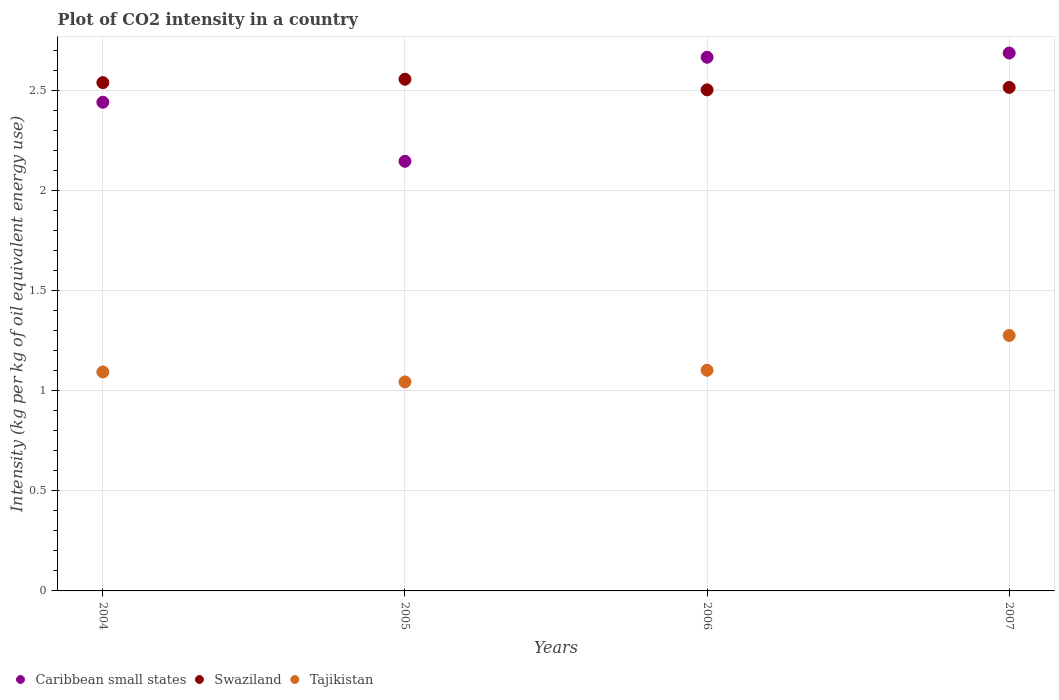How many different coloured dotlines are there?
Provide a short and direct response. 3. What is the CO2 intensity in in Tajikistan in 2005?
Provide a short and direct response. 1.04. Across all years, what is the maximum CO2 intensity in in Swaziland?
Provide a short and direct response. 2.55. Across all years, what is the minimum CO2 intensity in in Caribbean small states?
Provide a succinct answer. 2.15. In which year was the CO2 intensity in in Caribbean small states maximum?
Give a very brief answer. 2007. In which year was the CO2 intensity in in Tajikistan minimum?
Keep it short and to the point. 2005. What is the total CO2 intensity in in Tajikistan in the graph?
Provide a short and direct response. 4.51. What is the difference between the CO2 intensity in in Tajikistan in 2004 and that in 2006?
Your answer should be compact. -0.01. What is the difference between the CO2 intensity in in Tajikistan in 2004 and the CO2 intensity in in Swaziland in 2007?
Offer a terse response. -1.42. What is the average CO2 intensity in in Swaziland per year?
Your response must be concise. 2.53. In the year 2006, what is the difference between the CO2 intensity in in Caribbean small states and CO2 intensity in in Swaziland?
Your answer should be compact. 0.16. What is the ratio of the CO2 intensity in in Swaziland in 2006 to that in 2007?
Your response must be concise. 1. Is the CO2 intensity in in Swaziland in 2004 less than that in 2007?
Your response must be concise. No. Is the difference between the CO2 intensity in in Caribbean small states in 2006 and 2007 greater than the difference between the CO2 intensity in in Swaziland in 2006 and 2007?
Your answer should be very brief. No. What is the difference between the highest and the second highest CO2 intensity in in Caribbean small states?
Your answer should be very brief. 0.02. What is the difference between the highest and the lowest CO2 intensity in in Caribbean small states?
Provide a short and direct response. 0.54. Is the sum of the CO2 intensity in in Swaziland in 2005 and 2006 greater than the maximum CO2 intensity in in Tajikistan across all years?
Offer a very short reply. Yes. Does the CO2 intensity in in Caribbean small states monotonically increase over the years?
Offer a very short reply. No. Is the CO2 intensity in in Tajikistan strictly greater than the CO2 intensity in in Swaziland over the years?
Make the answer very short. No. Is the CO2 intensity in in Tajikistan strictly less than the CO2 intensity in in Swaziland over the years?
Provide a succinct answer. Yes. Are the values on the major ticks of Y-axis written in scientific E-notation?
Ensure brevity in your answer.  No. Where does the legend appear in the graph?
Provide a short and direct response. Bottom left. What is the title of the graph?
Offer a terse response. Plot of CO2 intensity in a country. Does "Faeroe Islands" appear as one of the legend labels in the graph?
Ensure brevity in your answer.  No. What is the label or title of the Y-axis?
Keep it short and to the point. Intensity (kg per kg of oil equivalent energy use). What is the Intensity (kg per kg of oil equivalent energy use) of Caribbean small states in 2004?
Make the answer very short. 2.44. What is the Intensity (kg per kg of oil equivalent energy use) in Swaziland in 2004?
Ensure brevity in your answer.  2.54. What is the Intensity (kg per kg of oil equivalent energy use) of Tajikistan in 2004?
Your answer should be very brief. 1.09. What is the Intensity (kg per kg of oil equivalent energy use) of Caribbean small states in 2005?
Make the answer very short. 2.15. What is the Intensity (kg per kg of oil equivalent energy use) in Swaziland in 2005?
Provide a succinct answer. 2.55. What is the Intensity (kg per kg of oil equivalent energy use) in Tajikistan in 2005?
Ensure brevity in your answer.  1.04. What is the Intensity (kg per kg of oil equivalent energy use) in Caribbean small states in 2006?
Your response must be concise. 2.66. What is the Intensity (kg per kg of oil equivalent energy use) of Swaziland in 2006?
Provide a short and direct response. 2.5. What is the Intensity (kg per kg of oil equivalent energy use) in Tajikistan in 2006?
Your response must be concise. 1.1. What is the Intensity (kg per kg of oil equivalent energy use) of Caribbean small states in 2007?
Ensure brevity in your answer.  2.69. What is the Intensity (kg per kg of oil equivalent energy use) of Swaziland in 2007?
Ensure brevity in your answer.  2.51. What is the Intensity (kg per kg of oil equivalent energy use) in Tajikistan in 2007?
Keep it short and to the point. 1.28. Across all years, what is the maximum Intensity (kg per kg of oil equivalent energy use) in Caribbean small states?
Your answer should be compact. 2.69. Across all years, what is the maximum Intensity (kg per kg of oil equivalent energy use) in Swaziland?
Offer a very short reply. 2.55. Across all years, what is the maximum Intensity (kg per kg of oil equivalent energy use) of Tajikistan?
Give a very brief answer. 1.28. Across all years, what is the minimum Intensity (kg per kg of oil equivalent energy use) of Caribbean small states?
Ensure brevity in your answer.  2.15. Across all years, what is the minimum Intensity (kg per kg of oil equivalent energy use) of Swaziland?
Ensure brevity in your answer.  2.5. Across all years, what is the minimum Intensity (kg per kg of oil equivalent energy use) of Tajikistan?
Keep it short and to the point. 1.04. What is the total Intensity (kg per kg of oil equivalent energy use) of Caribbean small states in the graph?
Your answer should be very brief. 9.94. What is the total Intensity (kg per kg of oil equivalent energy use) of Swaziland in the graph?
Your response must be concise. 10.11. What is the total Intensity (kg per kg of oil equivalent energy use) in Tajikistan in the graph?
Keep it short and to the point. 4.51. What is the difference between the Intensity (kg per kg of oil equivalent energy use) in Caribbean small states in 2004 and that in 2005?
Keep it short and to the point. 0.29. What is the difference between the Intensity (kg per kg of oil equivalent energy use) in Swaziland in 2004 and that in 2005?
Provide a succinct answer. -0.02. What is the difference between the Intensity (kg per kg of oil equivalent energy use) of Tajikistan in 2004 and that in 2005?
Your answer should be compact. 0.05. What is the difference between the Intensity (kg per kg of oil equivalent energy use) in Caribbean small states in 2004 and that in 2006?
Your answer should be very brief. -0.22. What is the difference between the Intensity (kg per kg of oil equivalent energy use) in Swaziland in 2004 and that in 2006?
Offer a very short reply. 0.04. What is the difference between the Intensity (kg per kg of oil equivalent energy use) in Tajikistan in 2004 and that in 2006?
Offer a very short reply. -0.01. What is the difference between the Intensity (kg per kg of oil equivalent energy use) of Caribbean small states in 2004 and that in 2007?
Provide a succinct answer. -0.25. What is the difference between the Intensity (kg per kg of oil equivalent energy use) in Swaziland in 2004 and that in 2007?
Your answer should be very brief. 0.02. What is the difference between the Intensity (kg per kg of oil equivalent energy use) in Tajikistan in 2004 and that in 2007?
Your response must be concise. -0.18. What is the difference between the Intensity (kg per kg of oil equivalent energy use) in Caribbean small states in 2005 and that in 2006?
Your response must be concise. -0.52. What is the difference between the Intensity (kg per kg of oil equivalent energy use) in Swaziland in 2005 and that in 2006?
Offer a very short reply. 0.05. What is the difference between the Intensity (kg per kg of oil equivalent energy use) of Tajikistan in 2005 and that in 2006?
Give a very brief answer. -0.06. What is the difference between the Intensity (kg per kg of oil equivalent energy use) of Caribbean small states in 2005 and that in 2007?
Your answer should be very brief. -0.54. What is the difference between the Intensity (kg per kg of oil equivalent energy use) in Swaziland in 2005 and that in 2007?
Provide a short and direct response. 0.04. What is the difference between the Intensity (kg per kg of oil equivalent energy use) of Tajikistan in 2005 and that in 2007?
Offer a very short reply. -0.23. What is the difference between the Intensity (kg per kg of oil equivalent energy use) in Caribbean small states in 2006 and that in 2007?
Provide a short and direct response. -0.02. What is the difference between the Intensity (kg per kg of oil equivalent energy use) in Swaziland in 2006 and that in 2007?
Keep it short and to the point. -0.01. What is the difference between the Intensity (kg per kg of oil equivalent energy use) in Tajikistan in 2006 and that in 2007?
Ensure brevity in your answer.  -0.17. What is the difference between the Intensity (kg per kg of oil equivalent energy use) of Caribbean small states in 2004 and the Intensity (kg per kg of oil equivalent energy use) of Swaziland in 2005?
Your answer should be very brief. -0.12. What is the difference between the Intensity (kg per kg of oil equivalent energy use) in Caribbean small states in 2004 and the Intensity (kg per kg of oil equivalent energy use) in Tajikistan in 2005?
Keep it short and to the point. 1.4. What is the difference between the Intensity (kg per kg of oil equivalent energy use) in Swaziland in 2004 and the Intensity (kg per kg of oil equivalent energy use) in Tajikistan in 2005?
Keep it short and to the point. 1.49. What is the difference between the Intensity (kg per kg of oil equivalent energy use) in Caribbean small states in 2004 and the Intensity (kg per kg of oil equivalent energy use) in Swaziland in 2006?
Keep it short and to the point. -0.06. What is the difference between the Intensity (kg per kg of oil equivalent energy use) of Caribbean small states in 2004 and the Intensity (kg per kg of oil equivalent energy use) of Tajikistan in 2006?
Make the answer very short. 1.34. What is the difference between the Intensity (kg per kg of oil equivalent energy use) of Swaziland in 2004 and the Intensity (kg per kg of oil equivalent energy use) of Tajikistan in 2006?
Give a very brief answer. 1.44. What is the difference between the Intensity (kg per kg of oil equivalent energy use) of Caribbean small states in 2004 and the Intensity (kg per kg of oil equivalent energy use) of Swaziland in 2007?
Make the answer very short. -0.07. What is the difference between the Intensity (kg per kg of oil equivalent energy use) of Caribbean small states in 2004 and the Intensity (kg per kg of oil equivalent energy use) of Tajikistan in 2007?
Give a very brief answer. 1.16. What is the difference between the Intensity (kg per kg of oil equivalent energy use) in Swaziland in 2004 and the Intensity (kg per kg of oil equivalent energy use) in Tajikistan in 2007?
Your answer should be compact. 1.26. What is the difference between the Intensity (kg per kg of oil equivalent energy use) in Caribbean small states in 2005 and the Intensity (kg per kg of oil equivalent energy use) in Swaziland in 2006?
Your answer should be compact. -0.36. What is the difference between the Intensity (kg per kg of oil equivalent energy use) in Caribbean small states in 2005 and the Intensity (kg per kg of oil equivalent energy use) in Tajikistan in 2006?
Your response must be concise. 1.04. What is the difference between the Intensity (kg per kg of oil equivalent energy use) of Swaziland in 2005 and the Intensity (kg per kg of oil equivalent energy use) of Tajikistan in 2006?
Offer a very short reply. 1.45. What is the difference between the Intensity (kg per kg of oil equivalent energy use) in Caribbean small states in 2005 and the Intensity (kg per kg of oil equivalent energy use) in Swaziland in 2007?
Your response must be concise. -0.37. What is the difference between the Intensity (kg per kg of oil equivalent energy use) in Caribbean small states in 2005 and the Intensity (kg per kg of oil equivalent energy use) in Tajikistan in 2007?
Your answer should be compact. 0.87. What is the difference between the Intensity (kg per kg of oil equivalent energy use) in Swaziland in 2005 and the Intensity (kg per kg of oil equivalent energy use) in Tajikistan in 2007?
Make the answer very short. 1.28. What is the difference between the Intensity (kg per kg of oil equivalent energy use) of Caribbean small states in 2006 and the Intensity (kg per kg of oil equivalent energy use) of Swaziland in 2007?
Offer a very short reply. 0.15. What is the difference between the Intensity (kg per kg of oil equivalent energy use) of Caribbean small states in 2006 and the Intensity (kg per kg of oil equivalent energy use) of Tajikistan in 2007?
Your response must be concise. 1.39. What is the difference between the Intensity (kg per kg of oil equivalent energy use) of Swaziland in 2006 and the Intensity (kg per kg of oil equivalent energy use) of Tajikistan in 2007?
Your answer should be compact. 1.23. What is the average Intensity (kg per kg of oil equivalent energy use) in Caribbean small states per year?
Your response must be concise. 2.48. What is the average Intensity (kg per kg of oil equivalent energy use) in Swaziland per year?
Give a very brief answer. 2.53. What is the average Intensity (kg per kg of oil equivalent energy use) in Tajikistan per year?
Provide a short and direct response. 1.13. In the year 2004, what is the difference between the Intensity (kg per kg of oil equivalent energy use) of Caribbean small states and Intensity (kg per kg of oil equivalent energy use) of Swaziland?
Your answer should be very brief. -0.1. In the year 2004, what is the difference between the Intensity (kg per kg of oil equivalent energy use) of Caribbean small states and Intensity (kg per kg of oil equivalent energy use) of Tajikistan?
Keep it short and to the point. 1.35. In the year 2004, what is the difference between the Intensity (kg per kg of oil equivalent energy use) of Swaziland and Intensity (kg per kg of oil equivalent energy use) of Tajikistan?
Your answer should be compact. 1.44. In the year 2005, what is the difference between the Intensity (kg per kg of oil equivalent energy use) in Caribbean small states and Intensity (kg per kg of oil equivalent energy use) in Swaziland?
Provide a succinct answer. -0.41. In the year 2005, what is the difference between the Intensity (kg per kg of oil equivalent energy use) of Caribbean small states and Intensity (kg per kg of oil equivalent energy use) of Tajikistan?
Offer a very short reply. 1.1. In the year 2005, what is the difference between the Intensity (kg per kg of oil equivalent energy use) in Swaziland and Intensity (kg per kg of oil equivalent energy use) in Tajikistan?
Your answer should be compact. 1.51. In the year 2006, what is the difference between the Intensity (kg per kg of oil equivalent energy use) of Caribbean small states and Intensity (kg per kg of oil equivalent energy use) of Swaziland?
Ensure brevity in your answer.  0.16. In the year 2006, what is the difference between the Intensity (kg per kg of oil equivalent energy use) in Caribbean small states and Intensity (kg per kg of oil equivalent energy use) in Tajikistan?
Provide a succinct answer. 1.56. In the year 2007, what is the difference between the Intensity (kg per kg of oil equivalent energy use) of Caribbean small states and Intensity (kg per kg of oil equivalent energy use) of Swaziland?
Ensure brevity in your answer.  0.17. In the year 2007, what is the difference between the Intensity (kg per kg of oil equivalent energy use) of Caribbean small states and Intensity (kg per kg of oil equivalent energy use) of Tajikistan?
Provide a succinct answer. 1.41. In the year 2007, what is the difference between the Intensity (kg per kg of oil equivalent energy use) in Swaziland and Intensity (kg per kg of oil equivalent energy use) in Tajikistan?
Your answer should be very brief. 1.24. What is the ratio of the Intensity (kg per kg of oil equivalent energy use) of Caribbean small states in 2004 to that in 2005?
Your answer should be compact. 1.14. What is the ratio of the Intensity (kg per kg of oil equivalent energy use) of Tajikistan in 2004 to that in 2005?
Offer a very short reply. 1.05. What is the ratio of the Intensity (kg per kg of oil equivalent energy use) in Caribbean small states in 2004 to that in 2006?
Your answer should be very brief. 0.92. What is the ratio of the Intensity (kg per kg of oil equivalent energy use) in Swaziland in 2004 to that in 2006?
Provide a short and direct response. 1.01. What is the ratio of the Intensity (kg per kg of oil equivalent energy use) in Caribbean small states in 2004 to that in 2007?
Provide a short and direct response. 0.91. What is the ratio of the Intensity (kg per kg of oil equivalent energy use) of Swaziland in 2004 to that in 2007?
Ensure brevity in your answer.  1.01. What is the ratio of the Intensity (kg per kg of oil equivalent energy use) of Caribbean small states in 2005 to that in 2006?
Provide a short and direct response. 0.81. What is the ratio of the Intensity (kg per kg of oil equivalent energy use) of Swaziland in 2005 to that in 2006?
Give a very brief answer. 1.02. What is the ratio of the Intensity (kg per kg of oil equivalent energy use) of Tajikistan in 2005 to that in 2006?
Your answer should be compact. 0.95. What is the ratio of the Intensity (kg per kg of oil equivalent energy use) in Caribbean small states in 2005 to that in 2007?
Offer a very short reply. 0.8. What is the ratio of the Intensity (kg per kg of oil equivalent energy use) in Swaziland in 2005 to that in 2007?
Give a very brief answer. 1.02. What is the ratio of the Intensity (kg per kg of oil equivalent energy use) in Tajikistan in 2005 to that in 2007?
Your response must be concise. 0.82. What is the ratio of the Intensity (kg per kg of oil equivalent energy use) in Caribbean small states in 2006 to that in 2007?
Give a very brief answer. 0.99. What is the ratio of the Intensity (kg per kg of oil equivalent energy use) in Swaziland in 2006 to that in 2007?
Your response must be concise. 1. What is the ratio of the Intensity (kg per kg of oil equivalent energy use) in Tajikistan in 2006 to that in 2007?
Keep it short and to the point. 0.86. What is the difference between the highest and the second highest Intensity (kg per kg of oil equivalent energy use) in Caribbean small states?
Your answer should be compact. 0.02. What is the difference between the highest and the second highest Intensity (kg per kg of oil equivalent energy use) of Swaziland?
Your answer should be compact. 0.02. What is the difference between the highest and the second highest Intensity (kg per kg of oil equivalent energy use) of Tajikistan?
Offer a very short reply. 0.17. What is the difference between the highest and the lowest Intensity (kg per kg of oil equivalent energy use) in Caribbean small states?
Your answer should be very brief. 0.54. What is the difference between the highest and the lowest Intensity (kg per kg of oil equivalent energy use) of Swaziland?
Your response must be concise. 0.05. What is the difference between the highest and the lowest Intensity (kg per kg of oil equivalent energy use) of Tajikistan?
Ensure brevity in your answer.  0.23. 